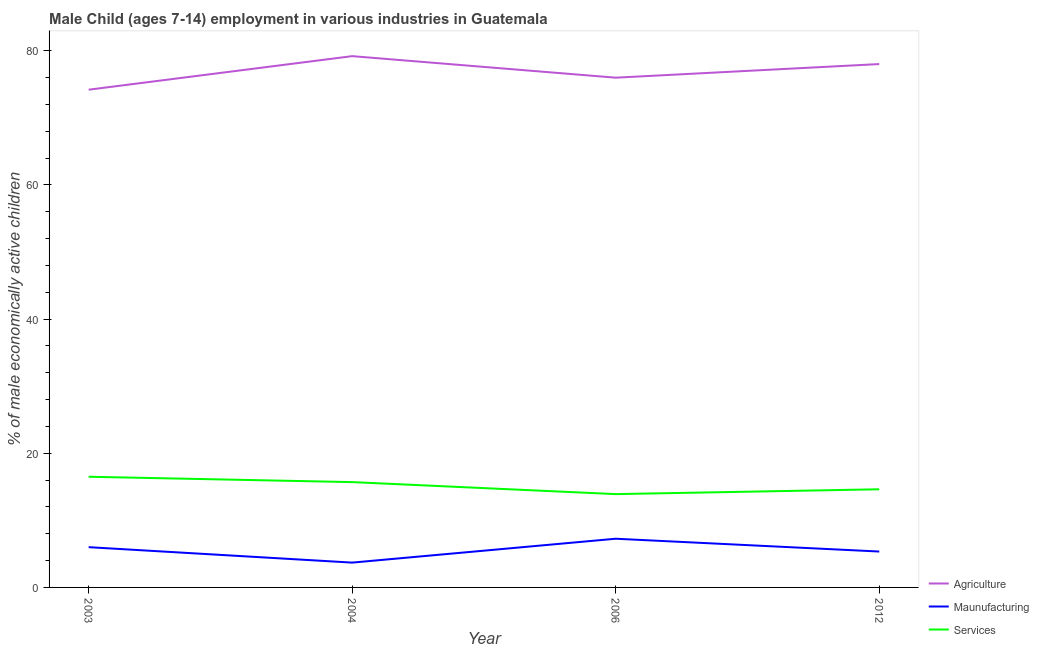Does the line corresponding to percentage of economically active children in agriculture intersect with the line corresponding to percentage of economically active children in services?
Ensure brevity in your answer.  No. Is the number of lines equal to the number of legend labels?
Your response must be concise. Yes. What is the percentage of economically active children in manufacturing in 2003?
Offer a terse response. 6. Across all years, what is the maximum percentage of economically active children in manufacturing?
Provide a succinct answer. 7.26. Across all years, what is the minimum percentage of economically active children in agriculture?
Make the answer very short. 74.2. In which year was the percentage of economically active children in manufacturing maximum?
Offer a terse response. 2006. What is the total percentage of economically active children in services in the graph?
Give a very brief answer. 60.74. What is the difference between the percentage of economically active children in agriculture in 2004 and that in 2006?
Offer a very short reply. 3.21. What is the difference between the percentage of economically active children in manufacturing in 2004 and the percentage of economically active children in agriculture in 2003?
Your response must be concise. -70.5. What is the average percentage of economically active children in services per year?
Keep it short and to the point. 15.19. In the year 2004, what is the difference between the percentage of economically active children in services and percentage of economically active children in manufacturing?
Your answer should be very brief. 12. In how many years, is the percentage of economically active children in manufacturing greater than 12 %?
Provide a succinct answer. 0. What is the ratio of the percentage of economically active children in agriculture in 2003 to that in 2012?
Make the answer very short. 0.95. What is the difference between the highest and the second highest percentage of economically active children in agriculture?
Keep it short and to the point. 1.18. What is the difference between the highest and the lowest percentage of economically active children in agriculture?
Provide a succinct answer. 5. Is the percentage of economically active children in manufacturing strictly less than the percentage of economically active children in services over the years?
Your response must be concise. Yes. What is the difference between two consecutive major ticks on the Y-axis?
Ensure brevity in your answer.  20. Are the values on the major ticks of Y-axis written in scientific E-notation?
Provide a short and direct response. No. Does the graph contain any zero values?
Ensure brevity in your answer.  No. Does the graph contain grids?
Provide a short and direct response. No. Where does the legend appear in the graph?
Offer a terse response. Bottom right. How many legend labels are there?
Give a very brief answer. 3. How are the legend labels stacked?
Make the answer very short. Vertical. What is the title of the graph?
Offer a very short reply. Male Child (ages 7-14) employment in various industries in Guatemala. Does "Industry" appear as one of the legend labels in the graph?
Ensure brevity in your answer.  No. What is the label or title of the Y-axis?
Your answer should be compact. % of male economically active children. What is the % of male economically active children of Agriculture in 2003?
Your response must be concise. 74.2. What is the % of male economically active children of Maunufacturing in 2003?
Your answer should be compact. 6. What is the % of male economically active children in Services in 2003?
Provide a succinct answer. 16.5. What is the % of male economically active children in Agriculture in 2004?
Offer a terse response. 79.2. What is the % of male economically active children of Maunufacturing in 2004?
Provide a short and direct response. 3.7. What is the % of male economically active children of Services in 2004?
Your answer should be compact. 15.7. What is the % of male economically active children in Agriculture in 2006?
Your response must be concise. 75.99. What is the % of male economically active children in Maunufacturing in 2006?
Your answer should be very brief. 7.26. What is the % of male economically active children of Services in 2006?
Give a very brief answer. 13.91. What is the % of male economically active children of Agriculture in 2012?
Your response must be concise. 78.02. What is the % of male economically active children of Maunufacturing in 2012?
Offer a terse response. 5.35. What is the % of male economically active children of Services in 2012?
Offer a very short reply. 14.63. Across all years, what is the maximum % of male economically active children of Agriculture?
Give a very brief answer. 79.2. Across all years, what is the maximum % of male economically active children in Maunufacturing?
Provide a short and direct response. 7.26. Across all years, what is the maximum % of male economically active children in Services?
Give a very brief answer. 16.5. Across all years, what is the minimum % of male economically active children of Agriculture?
Ensure brevity in your answer.  74.2. Across all years, what is the minimum % of male economically active children of Services?
Provide a short and direct response. 13.91. What is the total % of male economically active children of Agriculture in the graph?
Your answer should be very brief. 307.41. What is the total % of male economically active children in Maunufacturing in the graph?
Ensure brevity in your answer.  22.31. What is the total % of male economically active children of Services in the graph?
Provide a succinct answer. 60.74. What is the difference between the % of male economically active children in Services in 2003 and that in 2004?
Your answer should be compact. 0.8. What is the difference between the % of male economically active children in Agriculture in 2003 and that in 2006?
Your response must be concise. -1.79. What is the difference between the % of male economically active children of Maunufacturing in 2003 and that in 2006?
Make the answer very short. -1.26. What is the difference between the % of male economically active children in Services in 2003 and that in 2006?
Give a very brief answer. 2.59. What is the difference between the % of male economically active children of Agriculture in 2003 and that in 2012?
Provide a succinct answer. -3.82. What is the difference between the % of male economically active children of Maunufacturing in 2003 and that in 2012?
Provide a succinct answer. 0.65. What is the difference between the % of male economically active children in Services in 2003 and that in 2012?
Offer a very short reply. 1.87. What is the difference between the % of male economically active children of Agriculture in 2004 and that in 2006?
Offer a terse response. 3.21. What is the difference between the % of male economically active children in Maunufacturing in 2004 and that in 2006?
Ensure brevity in your answer.  -3.56. What is the difference between the % of male economically active children in Services in 2004 and that in 2006?
Offer a terse response. 1.79. What is the difference between the % of male economically active children of Agriculture in 2004 and that in 2012?
Your answer should be very brief. 1.18. What is the difference between the % of male economically active children in Maunufacturing in 2004 and that in 2012?
Your response must be concise. -1.65. What is the difference between the % of male economically active children in Services in 2004 and that in 2012?
Keep it short and to the point. 1.07. What is the difference between the % of male economically active children of Agriculture in 2006 and that in 2012?
Your response must be concise. -2.03. What is the difference between the % of male economically active children in Maunufacturing in 2006 and that in 2012?
Your answer should be very brief. 1.91. What is the difference between the % of male economically active children in Services in 2006 and that in 2012?
Offer a terse response. -0.72. What is the difference between the % of male economically active children of Agriculture in 2003 and the % of male economically active children of Maunufacturing in 2004?
Provide a short and direct response. 70.5. What is the difference between the % of male economically active children of Agriculture in 2003 and the % of male economically active children of Services in 2004?
Ensure brevity in your answer.  58.5. What is the difference between the % of male economically active children of Maunufacturing in 2003 and the % of male economically active children of Services in 2004?
Keep it short and to the point. -9.7. What is the difference between the % of male economically active children in Agriculture in 2003 and the % of male economically active children in Maunufacturing in 2006?
Make the answer very short. 66.94. What is the difference between the % of male economically active children of Agriculture in 2003 and the % of male economically active children of Services in 2006?
Provide a succinct answer. 60.29. What is the difference between the % of male economically active children of Maunufacturing in 2003 and the % of male economically active children of Services in 2006?
Give a very brief answer. -7.91. What is the difference between the % of male economically active children of Agriculture in 2003 and the % of male economically active children of Maunufacturing in 2012?
Give a very brief answer. 68.85. What is the difference between the % of male economically active children in Agriculture in 2003 and the % of male economically active children in Services in 2012?
Provide a short and direct response. 59.57. What is the difference between the % of male economically active children in Maunufacturing in 2003 and the % of male economically active children in Services in 2012?
Your answer should be compact. -8.63. What is the difference between the % of male economically active children in Agriculture in 2004 and the % of male economically active children in Maunufacturing in 2006?
Make the answer very short. 71.94. What is the difference between the % of male economically active children of Agriculture in 2004 and the % of male economically active children of Services in 2006?
Keep it short and to the point. 65.29. What is the difference between the % of male economically active children in Maunufacturing in 2004 and the % of male economically active children in Services in 2006?
Your answer should be compact. -10.21. What is the difference between the % of male economically active children of Agriculture in 2004 and the % of male economically active children of Maunufacturing in 2012?
Your answer should be compact. 73.85. What is the difference between the % of male economically active children of Agriculture in 2004 and the % of male economically active children of Services in 2012?
Make the answer very short. 64.57. What is the difference between the % of male economically active children in Maunufacturing in 2004 and the % of male economically active children in Services in 2012?
Offer a terse response. -10.93. What is the difference between the % of male economically active children in Agriculture in 2006 and the % of male economically active children in Maunufacturing in 2012?
Offer a terse response. 70.64. What is the difference between the % of male economically active children of Agriculture in 2006 and the % of male economically active children of Services in 2012?
Your response must be concise. 61.36. What is the difference between the % of male economically active children in Maunufacturing in 2006 and the % of male economically active children in Services in 2012?
Your answer should be compact. -7.37. What is the average % of male economically active children in Agriculture per year?
Ensure brevity in your answer.  76.85. What is the average % of male economically active children of Maunufacturing per year?
Your response must be concise. 5.58. What is the average % of male economically active children in Services per year?
Keep it short and to the point. 15.19. In the year 2003, what is the difference between the % of male economically active children in Agriculture and % of male economically active children in Maunufacturing?
Offer a terse response. 68.2. In the year 2003, what is the difference between the % of male economically active children in Agriculture and % of male economically active children in Services?
Make the answer very short. 57.7. In the year 2004, what is the difference between the % of male economically active children of Agriculture and % of male economically active children of Maunufacturing?
Give a very brief answer. 75.5. In the year 2004, what is the difference between the % of male economically active children in Agriculture and % of male economically active children in Services?
Keep it short and to the point. 63.5. In the year 2006, what is the difference between the % of male economically active children of Agriculture and % of male economically active children of Maunufacturing?
Offer a very short reply. 68.73. In the year 2006, what is the difference between the % of male economically active children of Agriculture and % of male economically active children of Services?
Make the answer very short. 62.08. In the year 2006, what is the difference between the % of male economically active children in Maunufacturing and % of male economically active children in Services?
Give a very brief answer. -6.65. In the year 2012, what is the difference between the % of male economically active children in Agriculture and % of male economically active children in Maunufacturing?
Provide a succinct answer. 72.67. In the year 2012, what is the difference between the % of male economically active children of Agriculture and % of male economically active children of Services?
Your response must be concise. 63.39. In the year 2012, what is the difference between the % of male economically active children in Maunufacturing and % of male economically active children in Services?
Provide a succinct answer. -9.28. What is the ratio of the % of male economically active children in Agriculture in 2003 to that in 2004?
Make the answer very short. 0.94. What is the ratio of the % of male economically active children in Maunufacturing in 2003 to that in 2004?
Offer a very short reply. 1.62. What is the ratio of the % of male economically active children in Services in 2003 to that in 2004?
Your answer should be compact. 1.05. What is the ratio of the % of male economically active children in Agriculture in 2003 to that in 2006?
Offer a very short reply. 0.98. What is the ratio of the % of male economically active children of Maunufacturing in 2003 to that in 2006?
Provide a short and direct response. 0.83. What is the ratio of the % of male economically active children of Services in 2003 to that in 2006?
Offer a terse response. 1.19. What is the ratio of the % of male economically active children in Agriculture in 2003 to that in 2012?
Ensure brevity in your answer.  0.95. What is the ratio of the % of male economically active children in Maunufacturing in 2003 to that in 2012?
Your answer should be very brief. 1.12. What is the ratio of the % of male economically active children of Services in 2003 to that in 2012?
Keep it short and to the point. 1.13. What is the ratio of the % of male economically active children of Agriculture in 2004 to that in 2006?
Provide a short and direct response. 1.04. What is the ratio of the % of male economically active children of Maunufacturing in 2004 to that in 2006?
Make the answer very short. 0.51. What is the ratio of the % of male economically active children in Services in 2004 to that in 2006?
Give a very brief answer. 1.13. What is the ratio of the % of male economically active children of Agriculture in 2004 to that in 2012?
Provide a succinct answer. 1.02. What is the ratio of the % of male economically active children in Maunufacturing in 2004 to that in 2012?
Keep it short and to the point. 0.69. What is the ratio of the % of male economically active children of Services in 2004 to that in 2012?
Offer a very short reply. 1.07. What is the ratio of the % of male economically active children in Agriculture in 2006 to that in 2012?
Offer a very short reply. 0.97. What is the ratio of the % of male economically active children of Maunufacturing in 2006 to that in 2012?
Provide a succinct answer. 1.36. What is the ratio of the % of male economically active children of Services in 2006 to that in 2012?
Ensure brevity in your answer.  0.95. What is the difference between the highest and the second highest % of male economically active children in Agriculture?
Offer a terse response. 1.18. What is the difference between the highest and the second highest % of male economically active children of Maunufacturing?
Provide a short and direct response. 1.26. What is the difference between the highest and the second highest % of male economically active children of Services?
Your answer should be compact. 0.8. What is the difference between the highest and the lowest % of male economically active children of Maunufacturing?
Offer a terse response. 3.56. What is the difference between the highest and the lowest % of male economically active children in Services?
Give a very brief answer. 2.59. 